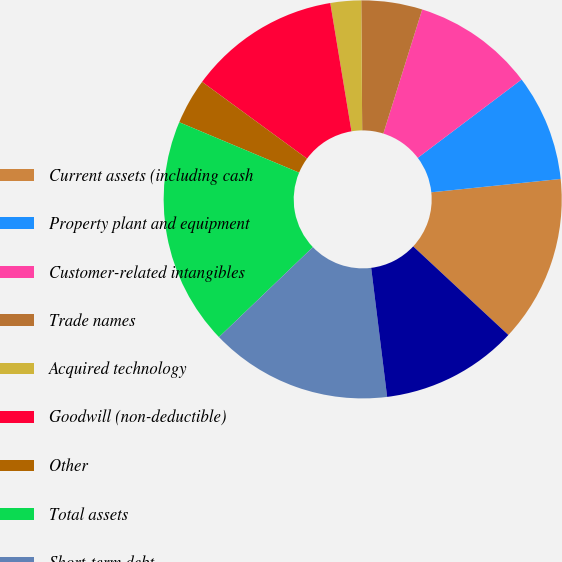Convert chart to OTSL. <chart><loc_0><loc_0><loc_500><loc_500><pie_chart><fcel>Current assets (including cash<fcel>Property plant and equipment<fcel>Customer-related intangibles<fcel>Trade names<fcel>Acquired technology<fcel>Goodwill (non-deductible)<fcel>Other<fcel>Total assets<fcel>Short-term debt<fcel>Current liabilities<nl><fcel>13.57%<fcel>8.65%<fcel>9.88%<fcel>4.95%<fcel>2.49%<fcel>12.34%<fcel>3.72%<fcel>18.5%<fcel>14.8%<fcel>11.11%<nl></chart> 